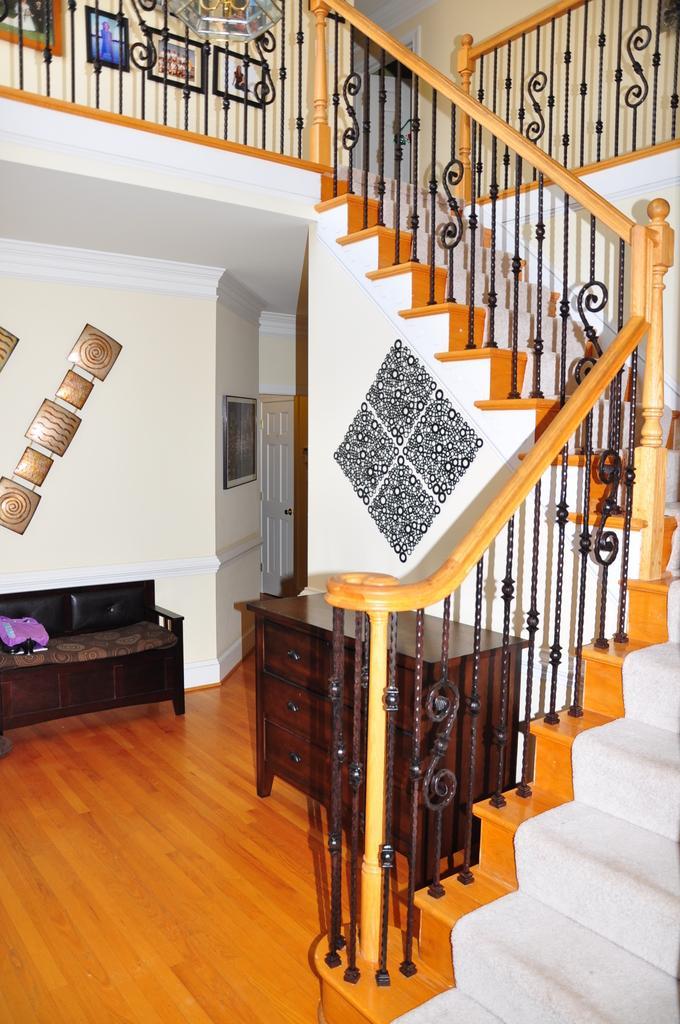Can you describe this image briefly? the picture there is a living room with staircase 